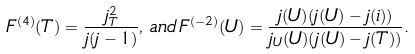<formula> <loc_0><loc_0><loc_500><loc_500>F ^ { ( 4 ) } ( T ) = \frac { j _ { T } ^ { 2 } } { j ( j - 1 ) } , \, a n d \, F ^ { ( - 2 ) } ( U ) = \frac { j ( U ) ( j ( U ) - j ( i ) ) } { j _ { U } ( U ) ( j ( U ) - j ( T ) ) } .</formula> 